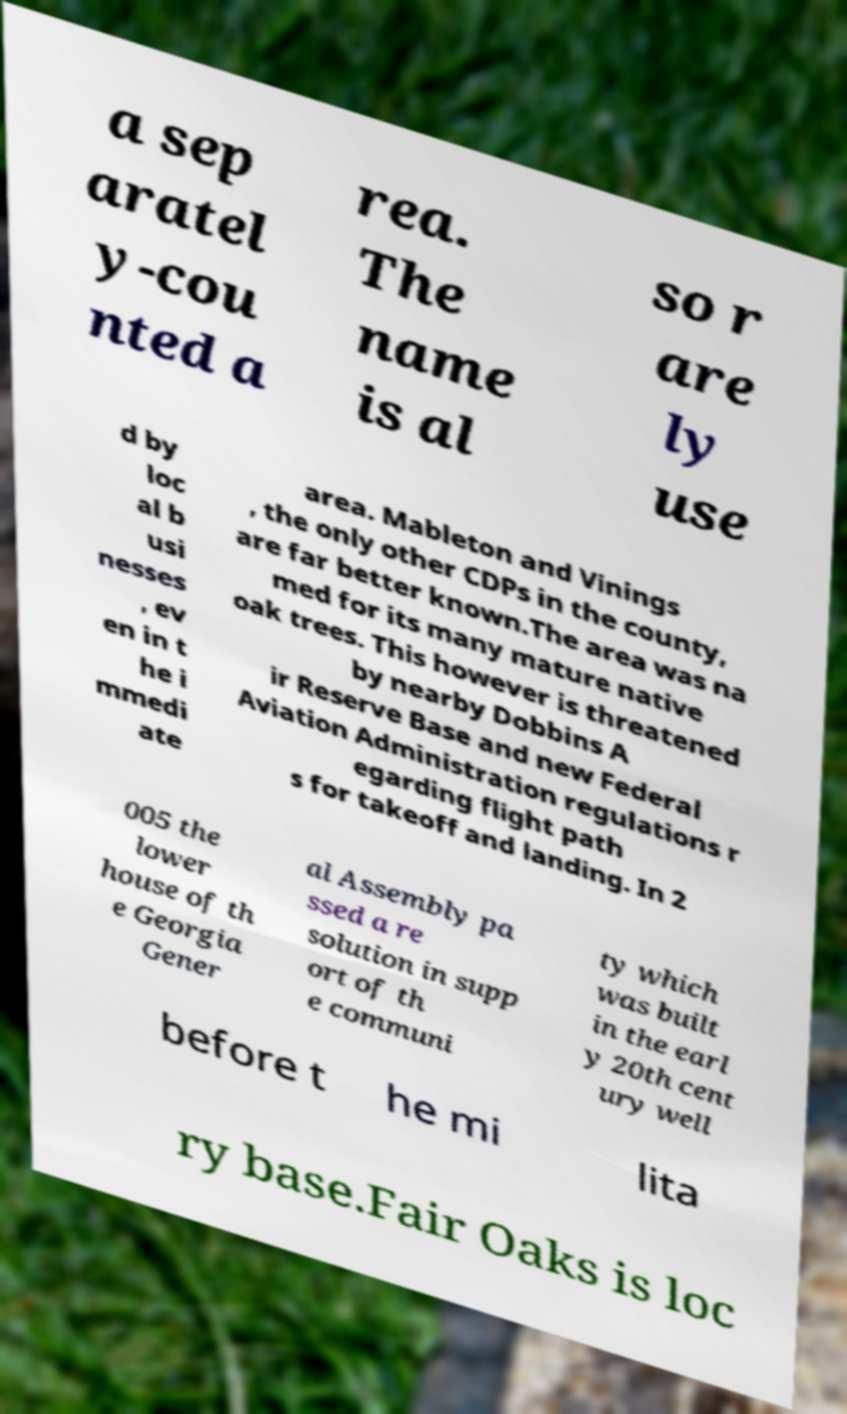Can you read and provide the text displayed in the image?This photo seems to have some interesting text. Can you extract and type it out for me? a sep aratel y-cou nted a rea. The name is al so r are ly use d by loc al b usi nesses , ev en in t he i mmedi ate area. Mableton and Vinings , the only other CDPs in the county, are far better known.The area was na med for its many mature native oak trees. This however is threatened by nearby Dobbins A ir Reserve Base and new Federal Aviation Administration regulations r egarding flight path s for takeoff and landing. In 2 005 the lower house of th e Georgia Gener al Assembly pa ssed a re solution in supp ort of th e communi ty which was built in the earl y 20th cent ury well before t he mi lita ry base.Fair Oaks is loc 